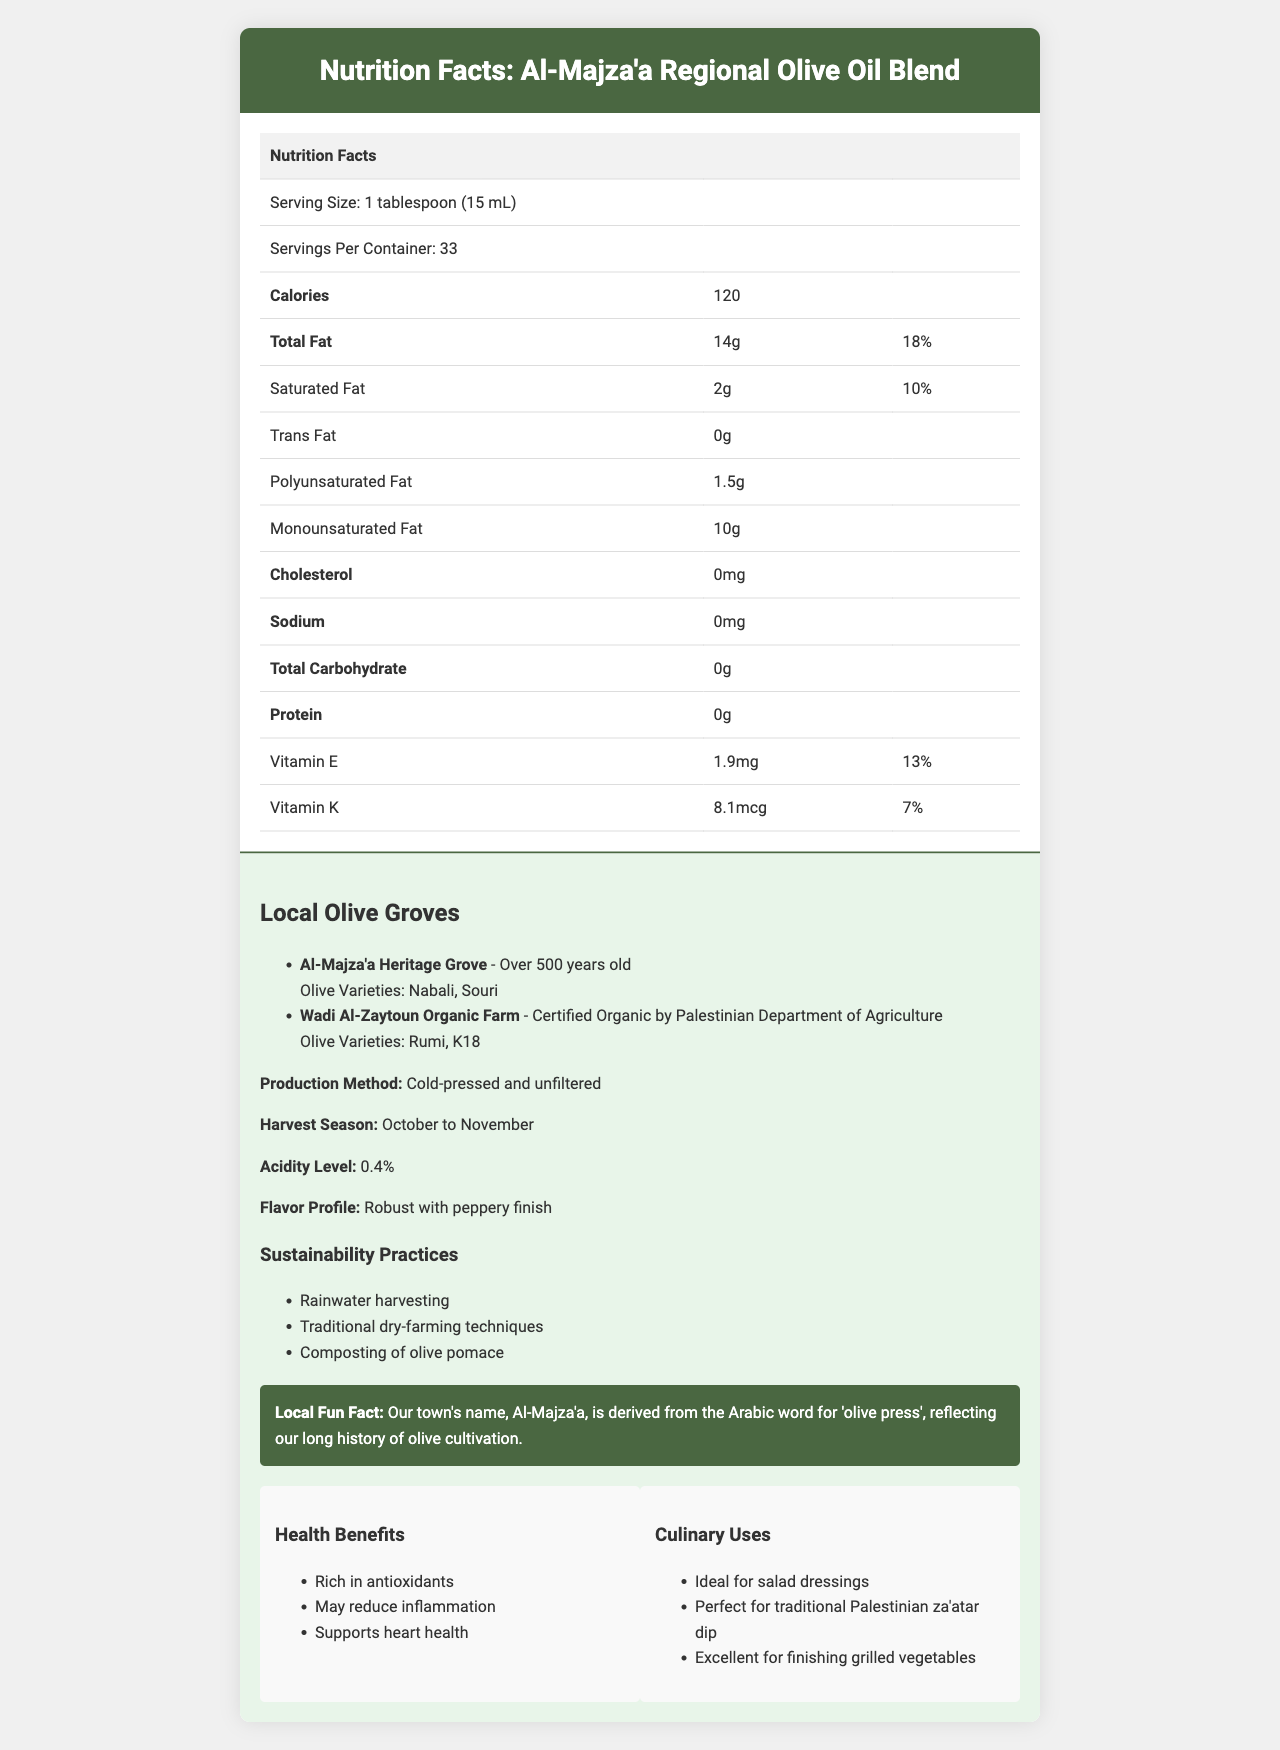what is the serving size of the Al-Majza'a Regional Olive Oil Blend? The document lists the serving size as 1 tablespoon (15 mL).
Answer: 1 tablespoon (15 mL) how many calories are there per serving of this olive oil blend? The document indicates that there are 120 calories per serving.
Answer: 120 calories what is the total fat content per serving? The document shows that the total fat content per serving is 14g.
Answer: 14g Does the Al-Majza'a Regional Olive Oil Blend contain any cholesterol? The document specifies that the olive oil blend contains 0mg of cholesterol.
Answer: No What is the harvest season for the olive oil production? The document states that the harvest season is from October to November.
Answer: October to November which of the following olive varieties are mentioned in the Al-Majza'a Heritage Grove?  A. Nabali and Souri B. Rumi and K18 C. Nabali and Rumi D. Souri and K18 The document mentions that the Al-Majza'a Heritage Grove has olive varieties Nabali and Souri.
Answer: A what is the acidity level of this olive oil blend? The document lists the acidity level as 0.4%.
Answer: 0.4% Which of the following practices is NOT mentioned under sustainability practices? A. Rainwater harvesting B. Use of chemical fertilizers C. Traditional dry-farming techniques D. Composting of olive pomace The document mentions rainwater harvesting, traditional dry-farming techniques, and composting of olive pomace, but not the use of chemical fertilizers.
Answer: B Is the Wadi Al-Zaytoun Organic Farm certified organic? The document indicates that the Wadi Al-Zaytoun Organic Farm is certified organic by the Palestinian Department of Agriculture.
Answer: Yes Describe the main idea of the document. The document contains nutritional information, details about local olive groves, production methods, sustainability practices, and other cultural facts pertinent to the Al-Majza'a Regional Olive Oil Blend.
Answer: The document provides a detailed nutrition facts label and additional information about the Al-Majza'a Regional Olive Oil Blend. It highlights the nutritional content, local olive groves, production methods, sustainability practices, and the cultural significance of olive oil production in Al-Majza'a. What is the main production method used for the olive oil? The document states that the olive oil is produced using cold-pressed and unfiltered methods.
Answer: Cold-pressed and unfiltered What is the flavor profile of this olive oil blend? The document describes the flavor profile as robust with a peppery finish.
Answer: Robust with peppery finish What is the daily value percentage of Vitamin E per serving? The document shows that the daily value percentage of Vitamin E per serving is 13%.
Answer: 13% Can you find the exact age of Wadi Al-Zaytoun Organic Farm? The document does not provide the exact age of Wadi Al-Zaytoun Organic Farm; it only mentions its certification.
Answer: Not enough information What are some culinary uses of the olive oil mentioned in the document? The document lists ideal for salad dressings, perfect for traditional Palestinian za'atar dip, and excellent for finishing grilled vegetables as culinary uses.
Answer: Ideal for salad dressings, perfect for traditional Palestinian za'atar dip, excellent for finishing grilled vegetables 